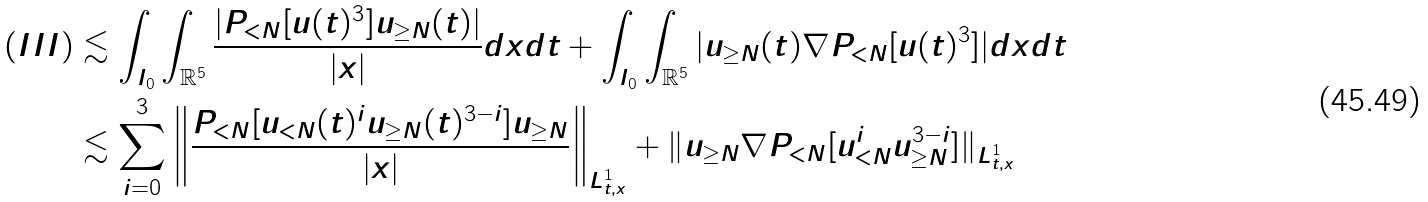Convert formula to latex. <formula><loc_0><loc_0><loc_500><loc_500>( I I I ) & \lesssim \int _ { I _ { 0 } } \int _ { \mathbb { R } ^ { 5 } } \frac { | P _ { < N } [ u ( t ) ^ { 3 } ] u _ { \geq N } ( t ) | } { | x | } d x d t + \int _ { I _ { 0 } } \int _ { \mathbb { R } ^ { 5 } } | u _ { \geq N } ( t ) \nabla P _ { < N } [ u ( t ) ^ { 3 } ] | d x d t \\ & \lesssim \sum _ { i = 0 } ^ { 3 } \left \| \frac { P _ { < N } [ u _ { < N } ( t ) ^ { i } u _ { \geq N } ( t ) ^ { 3 - i } ] u _ { \geq N } } { | x | } \right \| _ { L _ { t , x } ^ { 1 } } + \| u _ { \geq N } \nabla P _ { < N } [ u _ { < N } ^ { i } u _ { \geq N } ^ { 3 - i } ] \| _ { L _ { t , x } ^ { 1 } }</formula> 